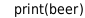<code> <loc_0><loc_0><loc_500><loc_500><_Python_>
print(beer)</code> 